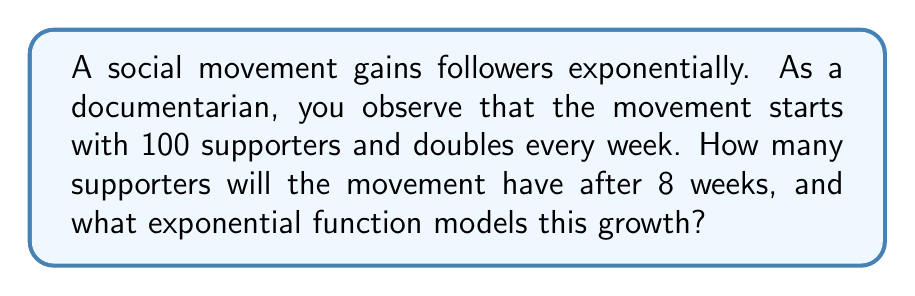Could you help me with this problem? Let's approach this step-by-step:

1) The initial number of supporters is 100, and it doubles every week. This means we're dealing with exponential growth.

2) The general form of an exponential function is:

   $$ f(t) = a \cdot b^t $$

   where $a$ is the initial value, $b$ is the growth factor, and $t$ is the time.

3) In this case:
   - $a = 100$ (initial supporters)
   - $b = 2$ (doubles each week)
   - $t$ will be the number of weeks

4) So our function is:

   $$ f(t) = 100 \cdot 2^t $$

5) To find the number of supporters after 8 weeks, we substitute $t = 8$:

   $$ f(8) = 100 \cdot 2^8 $$

6) Calculate $2^8$:
   $$ 2^8 = 256 $$

7) Multiply:
   $$ 100 \cdot 256 = 25,600 $$

Therefore, after 8 weeks, the movement will have 25,600 supporters.
Answer: 25,600 supporters; $f(t) = 100 \cdot 2^t$ 